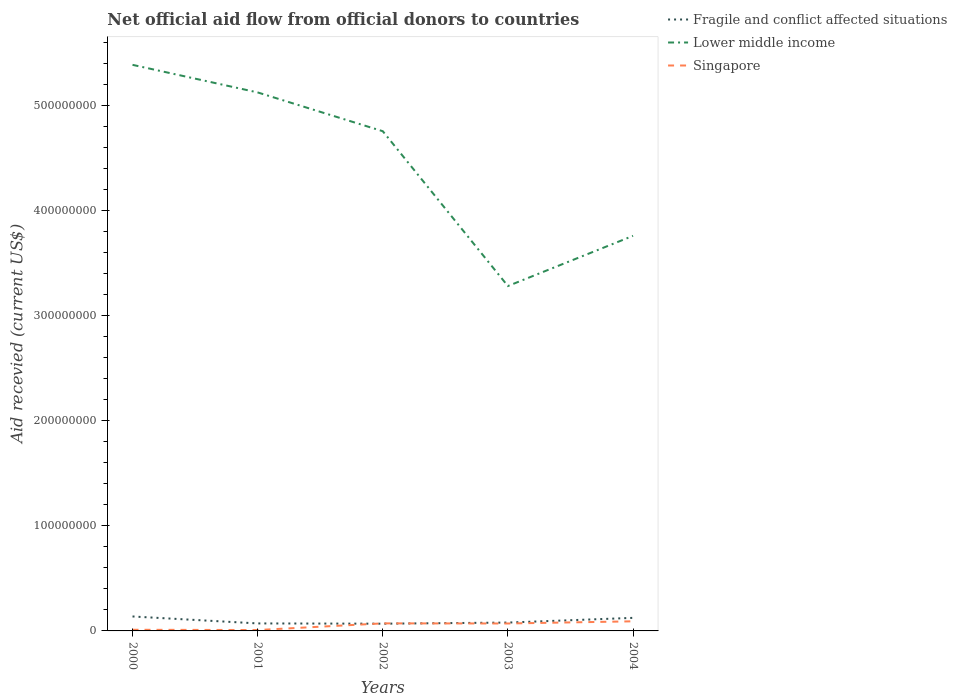How many different coloured lines are there?
Offer a very short reply. 3. Does the line corresponding to Lower middle income intersect with the line corresponding to Fragile and conflict affected situations?
Offer a very short reply. No. Is the number of lines equal to the number of legend labels?
Offer a very short reply. Yes. Across all years, what is the maximum total aid received in Fragile and conflict affected situations?
Make the answer very short. 6.88e+06. What is the total total aid received in Lower middle income in the graph?
Give a very brief answer. 1.47e+08. What is the difference between the highest and the second highest total aid received in Singapore?
Keep it short and to the point. 8.29e+06. How many lines are there?
Offer a terse response. 3. Does the graph contain any zero values?
Your answer should be very brief. No. Does the graph contain grids?
Provide a short and direct response. No. Where does the legend appear in the graph?
Ensure brevity in your answer.  Top right. How many legend labels are there?
Offer a terse response. 3. What is the title of the graph?
Provide a succinct answer. Net official aid flow from official donors to countries. Does "Mozambique" appear as one of the legend labels in the graph?
Keep it short and to the point. No. What is the label or title of the Y-axis?
Provide a short and direct response. Aid recevied (current US$). What is the Aid recevied (current US$) in Fragile and conflict affected situations in 2000?
Provide a short and direct response. 1.38e+07. What is the Aid recevied (current US$) of Lower middle income in 2000?
Make the answer very short. 5.39e+08. What is the Aid recevied (current US$) in Singapore in 2000?
Make the answer very short. 1.09e+06. What is the Aid recevied (current US$) in Fragile and conflict affected situations in 2001?
Your answer should be compact. 7.14e+06. What is the Aid recevied (current US$) in Lower middle income in 2001?
Your answer should be compact. 5.12e+08. What is the Aid recevied (current US$) of Singapore in 2001?
Offer a terse response. 8.50e+05. What is the Aid recevied (current US$) in Fragile and conflict affected situations in 2002?
Your answer should be very brief. 6.88e+06. What is the Aid recevied (current US$) of Lower middle income in 2002?
Offer a very short reply. 4.76e+08. What is the Aid recevied (current US$) in Singapore in 2002?
Ensure brevity in your answer.  7.19e+06. What is the Aid recevied (current US$) in Fragile and conflict affected situations in 2003?
Your response must be concise. 7.95e+06. What is the Aid recevied (current US$) in Lower middle income in 2003?
Offer a terse response. 3.28e+08. What is the Aid recevied (current US$) in Singapore in 2003?
Your response must be concise. 7.07e+06. What is the Aid recevied (current US$) in Fragile and conflict affected situations in 2004?
Keep it short and to the point. 1.24e+07. What is the Aid recevied (current US$) of Lower middle income in 2004?
Provide a short and direct response. 3.76e+08. What is the Aid recevied (current US$) in Singapore in 2004?
Provide a succinct answer. 9.14e+06. Across all years, what is the maximum Aid recevied (current US$) of Fragile and conflict affected situations?
Offer a very short reply. 1.38e+07. Across all years, what is the maximum Aid recevied (current US$) in Lower middle income?
Give a very brief answer. 5.39e+08. Across all years, what is the maximum Aid recevied (current US$) of Singapore?
Provide a short and direct response. 9.14e+06. Across all years, what is the minimum Aid recevied (current US$) in Fragile and conflict affected situations?
Your response must be concise. 6.88e+06. Across all years, what is the minimum Aid recevied (current US$) of Lower middle income?
Offer a very short reply. 3.28e+08. Across all years, what is the minimum Aid recevied (current US$) of Singapore?
Provide a short and direct response. 8.50e+05. What is the total Aid recevied (current US$) of Fragile and conflict affected situations in the graph?
Your answer should be very brief. 4.82e+07. What is the total Aid recevied (current US$) of Lower middle income in the graph?
Make the answer very short. 2.23e+09. What is the total Aid recevied (current US$) in Singapore in the graph?
Keep it short and to the point. 2.53e+07. What is the difference between the Aid recevied (current US$) of Fragile and conflict affected situations in 2000 and that in 2001?
Offer a very short reply. 6.61e+06. What is the difference between the Aid recevied (current US$) in Lower middle income in 2000 and that in 2001?
Your answer should be very brief. 2.62e+07. What is the difference between the Aid recevied (current US$) in Singapore in 2000 and that in 2001?
Offer a very short reply. 2.40e+05. What is the difference between the Aid recevied (current US$) of Fragile and conflict affected situations in 2000 and that in 2002?
Give a very brief answer. 6.87e+06. What is the difference between the Aid recevied (current US$) in Lower middle income in 2000 and that in 2002?
Offer a terse response. 6.32e+07. What is the difference between the Aid recevied (current US$) of Singapore in 2000 and that in 2002?
Your answer should be very brief. -6.10e+06. What is the difference between the Aid recevied (current US$) in Fragile and conflict affected situations in 2000 and that in 2003?
Keep it short and to the point. 5.80e+06. What is the difference between the Aid recevied (current US$) of Lower middle income in 2000 and that in 2003?
Your response must be concise. 2.10e+08. What is the difference between the Aid recevied (current US$) of Singapore in 2000 and that in 2003?
Give a very brief answer. -5.98e+06. What is the difference between the Aid recevied (current US$) in Fragile and conflict affected situations in 2000 and that in 2004?
Provide a succinct answer. 1.32e+06. What is the difference between the Aid recevied (current US$) in Lower middle income in 2000 and that in 2004?
Offer a terse response. 1.63e+08. What is the difference between the Aid recevied (current US$) in Singapore in 2000 and that in 2004?
Provide a succinct answer. -8.05e+06. What is the difference between the Aid recevied (current US$) of Fragile and conflict affected situations in 2001 and that in 2002?
Provide a short and direct response. 2.60e+05. What is the difference between the Aid recevied (current US$) of Lower middle income in 2001 and that in 2002?
Your answer should be compact. 3.69e+07. What is the difference between the Aid recevied (current US$) in Singapore in 2001 and that in 2002?
Your answer should be compact. -6.34e+06. What is the difference between the Aid recevied (current US$) in Fragile and conflict affected situations in 2001 and that in 2003?
Offer a very short reply. -8.10e+05. What is the difference between the Aid recevied (current US$) of Lower middle income in 2001 and that in 2003?
Your answer should be compact. 1.84e+08. What is the difference between the Aid recevied (current US$) of Singapore in 2001 and that in 2003?
Give a very brief answer. -6.22e+06. What is the difference between the Aid recevied (current US$) in Fragile and conflict affected situations in 2001 and that in 2004?
Ensure brevity in your answer.  -5.29e+06. What is the difference between the Aid recevied (current US$) in Lower middle income in 2001 and that in 2004?
Your response must be concise. 1.36e+08. What is the difference between the Aid recevied (current US$) in Singapore in 2001 and that in 2004?
Provide a succinct answer. -8.29e+06. What is the difference between the Aid recevied (current US$) in Fragile and conflict affected situations in 2002 and that in 2003?
Your answer should be compact. -1.07e+06. What is the difference between the Aid recevied (current US$) of Lower middle income in 2002 and that in 2003?
Offer a very short reply. 1.47e+08. What is the difference between the Aid recevied (current US$) of Singapore in 2002 and that in 2003?
Give a very brief answer. 1.20e+05. What is the difference between the Aid recevied (current US$) in Fragile and conflict affected situations in 2002 and that in 2004?
Your response must be concise. -5.55e+06. What is the difference between the Aid recevied (current US$) in Lower middle income in 2002 and that in 2004?
Provide a short and direct response. 9.96e+07. What is the difference between the Aid recevied (current US$) in Singapore in 2002 and that in 2004?
Provide a succinct answer. -1.95e+06. What is the difference between the Aid recevied (current US$) in Fragile and conflict affected situations in 2003 and that in 2004?
Keep it short and to the point. -4.48e+06. What is the difference between the Aid recevied (current US$) in Lower middle income in 2003 and that in 2004?
Offer a very short reply. -4.78e+07. What is the difference between the Aid recevied (current US$) of Singapore in 2003 and that in 2004?
Ensure brevity in your answer.  -2.07e+06. What is the difference between the Aid recevied (current US$) of Fragile and conflict affected situations in 2000 and the Aid recevied (current US$) of Lower middle income in 2001?
Ensure brevity in your answer.  -4.99e+08. What is the difference between the Aid recevied (current US$) of Fragile and conflict affected situations in 2000 and the Aid recevied (current US$) of Singapore in 2001?
Ensure brevity in your answer.  1.29e+07. What is the difference between the Aid recevied (current US$) in Lower middle income in 2000 and the Aid recevied (current US$) in Singapore in 2001?
Offer a terse response. 5.38e+08. What is the difference between the Aid recevied (current US$) of Fragile and conflict affected situations in 2000 and the Aid recevied (current US$) of Lower middle income in 2002?
Your answer should be compact. -4.62e+08. What is the difference between the Aid recevied (current US$) of Fragile and conflict affected situations in 2000 and the Aid recevied (current US$) of Singapore in 2002?
Keep it short and to the point. 6.56e+06. What is the difference between the Aid recevied (current US$) in Lower middle income in 2000 and the Aid recevied (current US$) in Singapore in 2002?
Ensure brevity in your answer.  5.32e+08. What is the difference between the Aid recevied (current US$) of Fragile and conflict affected situations in 2000 and the Aid recevied (current US$) of Lower middle income in 2003?
Your answer should be very brief. -3.14e+08. What is the difference between the Aid recevied (current US$) in Fragile and conflict affected situations in 2000 and the Aid recevied (current US$) in Singapore in 2003?
Offer a very short reply. 6.68e+06. What is the difference between the Aid recevied (current US$) of Lower middle income in 2000 and the Aid recevied (current US$) of Singapore in 2003?
Offer a terse response. 5.32e+08. What is the difference between the Aid recevied (current US$) in Fragile and conflict affected situations in 2000 and the Aid recevied (current US$) in Lower middle income in 2004?
Your answer should be compact. -3.62e+08. What is the difference between the Aid recevied (current US$) in Fragile and conflict affected situations in 2000 and the Aid recevied (current US$) in Singapore in 2004?
Make the answer very short. 4.61e+06. What is the difference between the Aid recevied (current US$) in Lower middle income in 2000 and the Aid recevied (current US$) in Singapore in 2004?
Ensure brevity in your answer.  5.30e+08. What is the difference between the Aid recevied (current US$) in Fragile and conflict affected situations in 2001 and the Aid recevied (current US$) in Lower middle income in 2002?
Your answer should be very brief. -4.68e+08. What is the difference between the Aid recevied (current US$) in Lower middle income in 2001 and the Aid recevied (current US$) in Singapore in 2002?
Offer a terse response. 5.05e+08. What is the difference between the Aid recevied (current US$) of Fragile and conflict affected situations in 2001 and the Aid recevied (current US$) of Lower middle income in 2003?
Provide a short and direct response. -3.21e+08. What is the difference between the Aid recevied (current US$) of Fragile and conflict affected situations in 2001 and the Aid recevied (current US$) of Singapore in 2003?
Keep it short and to the point. 7.00e+04. What is the difference between the Aid recevied (current US$) of Lower middle income in 2001 and the Aid recevied (current US$) of Singapore in 2003?
Your response must be concise. 5.05e+08. What is the difference between the Aid recevied (current US$) of Fragile and conflict affected situations in 2001 and the Aid recevied (current US$) of Lower middle income in 2004?
Your response must be concise. -3.69e+08. What is the difference between the Aid recevied (current US$) in Lower middle income in 2001 and the Aid recevied (current US$) in Singapore in 2004?
Offer a very short reply. 5.03e+08. What is the difference between the Aid recevied (current US$) in Fragile and conflict affected situations in 2002 and the Aid recevied (current US$) in Lower middle income in 2003?
Provide a short and direct response. -3.21e+08. What is the difference between the Aid recevied (current US$) of Fragile and conflict affected situations in 2002 and the Aid recevied (current US$) of Singapore in 2003?
Give a very brief answer. -1.90e+05. What is the difference between the Aid recevied (current US$) in Lower middle income in 2002 and the Aid recevied (current US$) in Singapore in 2003?
Provide a short and direct response. 4.68e+08. What is the difference between the Aid recevied (current US$) in Fragile and conflict affected situations in 2002 and the Aid recevied (current US$) in Lower middle income in 2004?
Your answer should be compact. -3.69e+08. What is the difference between the Aid recevied (current US$) of Fragile and conflict affected situations in 2002 and the Aid recevied (current US$) of Singapore in 2004?
Provide a succinct answer. -2.26e+06. What is the difference between the Aid recevied (current US$) of Lower middle income in 2002 and the Aid recevied (current US$) of Singapore in 2004?
Your answer should be compact. 4.66e+08. What is the difference between the Aid recevied (current US$) in Fragile and conflict affected situations in 2003 and the Aid recevied (current US$) in Lower middle income in 2004?
Your answer should be very brief. -3.68e+08. What is the difference between the Aid recevied (current US$) in Fragile and conflict affected situations in 2003 and the Aid recevied (current US$) in Singapore in 2004?
Make the answer very short. -1.19e+06. What is the difference between the Aid recevied (current US$) of Lower middle income in 2003 and the Aid recevied (current US$) of Singapore in 2004?
Your answer should be very brief. 3.19e+08. What is the average Aid recevied (current US$) of Fragile and conflict affected situations per year?
Your answer should be very brief. 9.63e+06. What is the average Aid recevied (current US$) of Lower middle income per year?
Provide a succinct answer. 4.46e+08. What is the average Aid recevied (current US$) of Singapore per year?
Offer a terse response. 5.07e+06. In the year 2000, what is the difference between the Aid recevied (current US$) in Fragile and conflict affected situations and Aid recevied (current US$) in Lower middle income?
Your response must be concise. -5.25e+08. In the year 2000, what is the difference between the Aid recevied (current US$) in Fragile and conflict affected situations and Aid recevied (current US$) in Singapore?
Offer a terse response. 1.27e+07. In the year 2000, what is the difference between the Aid recevied (current US$) in Lower middle income and Aid recevied (current US$) in Singapore?
Offer a terse response. 5.38e+08. In the year 2001, what is the difference between the Aid recevied (current US$) in Fragile and conflict affected situations and Aid recevied (current US$) in Lower middle income?
Provide a short and direct response. -5.05e+08. In the year 2001, what is the difference between the Aid recevied (current US$) of Fragile and conflict affected situations and Aid recevied (current US$) of Singapore?
Keep it short and to the point. 6.29e+06. In the year 2001, what is the difference between the Aid recevied (current US$) of Lower middle income and Aid recevied (current US$) of Singapore?
Your answer should be very brief. 5.12e+08. In the year 2002, what is the difference between the Aid recevied (current US$) in Fragile and conflict affected situations and Aid recevied (current US$) in Lower middle income?
Provide a short and direct response. -4.69e+08. In the year 2002, what is the difference between the Aid recevied (current US$) in Fragile and conflict affected situations and Aid recevied (current US$) in Singapore?
Your answer should be compact. -3.10e+05. In the year 2002, what is the difference between the Aid recevied (current US$) of Lower middle income and Aid recevied (current US$) of Singapore?
Make the answer very short. 4.68e+08. In the year 2003, what is the difference between the Aid recevied (current US$) in Fragile and conflict affected situations and Aid recevied (current US$) in Lower middle income?
Keep it short and to the point. -3.20e+08. In the year 2003, what is the difference between the Aid recevied (current US$) in Fragile and conflict affected situations and Aid recevied (current US$) in Singapore?
Your response must be concise. 8.80e+05. In the year 2003, what is the difference between the Aid recevied (current US$) in Lower middle income and Aid recevied (current US$) in Singapore?
Provide a succinct answer. 3.21e+08. In the year 2004, what is the difference between the Aid recevied (current US$) in Fragile and conflict affected situations and Aid recevied (current US$) in Lower middle income?
Provide a succinct answer. -3.64e+08. In the year 2004, what is the difference between the Aid recevied (current US$) in Fragile and conflict affected situations and Aid recevied (current US$) in Singapore?
Ensure brevity in your answer.  3.29e+06. In the year 2004, what is the difference between the Aid recevied (current US$) of Lower middle income and Aid recevied (current US$) of Singapore?
Provide a succinct answer. 3.67e+08. What is the ratio of the Aid recevied (current US$) in Fragile and conflict affected situations in 2000 to that in 2001?
Give a very brief answer. 1.93. What is the ratio of the Aid recevied (current US$) in Lower middle income in 2000 to that in 2001?
Provide a short and direct response. 1.05. What is the ratio of the Aid recevied (current US$) of Singapore in 2000 to that in 2001?
Provide a succinct answer. 1.28. What is the ratio of the Aid recevied (current US$) of Fragile and conflict affected situations in 2000 to that in 2002?
Make the answer very short. 2. What is the ratio of the Aid recevied (current US$) of Lower middle income in 2000 to that in 2002?
Ensure brevity in your answer.  1.13. What is the ratio of the Aid recevied (current US$) of Singapore in 2000 to that in 2002?
Ensure brevity in your answer.  0.15. What is the ratio of the Aid recevied (current US$) in Fragile and conflict affected situations in 2000 to that in 2003?
Make the answer very short. 1.73. What is the ratio of the Aid recevied (current US$) of Lower middle income in 2000 to that in 2003?
Offer a very short reply. 1.64. What is the ratio of the Aid recevied (current US$) in Singapore in 2000 to that in 2003?
Ensure brevity in your answer.  0.15. What is the ratio of the Aid recevied (current US$) of Fragile and conflict affected situations in 2000 to that in 2004?
Keep it short and to the point. 1.11. What is the ratio of the Aid recevied (current US$) of Lower middle income in 2000 to that in 2004?
Provide a short and direct response. 1.43. What is the ratio of the Aid recevied (current US$) of Singapore in 2000 to that in 2004?
Your answer should be compact. 0.12. What is the ratio of the Aid recevied (current US$) in Fragile and conflict affected situations in 2001 to that in 2002?
Your answer should be very brief. 1.04. What is the ratio of the Aid recevied (current US$) of Lower middle income in 2001 to that in 2002?
Provide a short and direct response. 1.08. What is the ratio of the Aid recevied (current US$) of Singapore in 2001 to that in 2002?
Your answer should be very brief. 0.12. What is the ratio of the Aid recevied (current US$) of Fragile and conflict affected situations in 2001 to that in 2003?
Keep it short and to the point. 0.9. What is the ratio of the Aid recevied (current US$) of Lower middle income in 2001 to that in 2003?
Keep it short and to the point. 1.56. What is the ratio of the Aid recevied (current US$) of Singapore in 2001 to that in 2003?
Your answer should be compact. 0.12. What is the ratio of the Aid recevied (current US$) of Fragile and conflict affected situations in 2001 to that in 2004?
Make the answer very short. 0.57. What is the ratio of the Aid recevied (current US$) in Lower middle income in 2001 to that in 2004?
Provide a short and direct response. 1.36. What is the ratio of the Aid recevied (current US$) in Singapore in 2001 to that in 2004?
Your response must be concise. 0.09. What is the ratio of the Aid recevied (current US$) in Fragile and conflict affected situations in 2002 to that in 2003?
Your answer should be very brief. 0.87. What is the ratio of the Aid recevied (current US$) in Lower middle income in 2002 to that in 2003?
Provide a succinct answer. 1.45. What is the ratio of the Aid recevied (current US$) in Singapore in 2002 to that in 2003?
Offer a terse response. 1.02. What is the ratio of the Aid recevied (current US$) of Fragile and conflict affected situations in 2002 to that in 2004?
Make the answer very short. 0.55. What is the ratio of the Aid recevied (current US$) of Lower middle income in 2002 to that in 2004?
Provide a succinct answer. 1.26. What is the ratio of the Aid recevied (current US$) of Singapore in 2002 to that in 2004?
Your answer should be compact. 0.79. What is the ratio of the Aid recevied (current US$) in Fragile and conflict affected situations in 2003 to that in 2004?
Your answer should be compact. 0.64. What is the ratio of the Aid recevied (current US$) in Lower middle income in 2003 to that in 2004?
Offer a very short reply. 0.87. What is the ratio of the Aid recevied (current US$) of Singapore in 2003 to that in 2004?
Your answer should be compact. 0.77. What is the difference between the highest and the second highest Aid recevied (current US$) of Fragile and conflict affected situations?
Offer a very short reply. 1.32e+06. What is the difference between the highest and the second highest Aid recevied (current US$) of Lower middle income?
Ensure brevity in your answer.  2.62e+07. What is the difference between the highest and the second highest Aid recevied (current US$) of Singapore?
Make the answer very short. 1.95e+06. What is the difference between the highest and the lowest Aid recevied (current US$) of Fragile and conflict affected situations?
Keep it short and to the point. 6.87e+06. What is the difference between the highest and the lowest Aid recevied (current US$) of Lower middle income?
Offer a very short reply. 2.10e+08. What is the difference between the highest and the lowest Aid recevied (current US$) in Singapore?
Keep it short and to the point. 8.29e+06. 